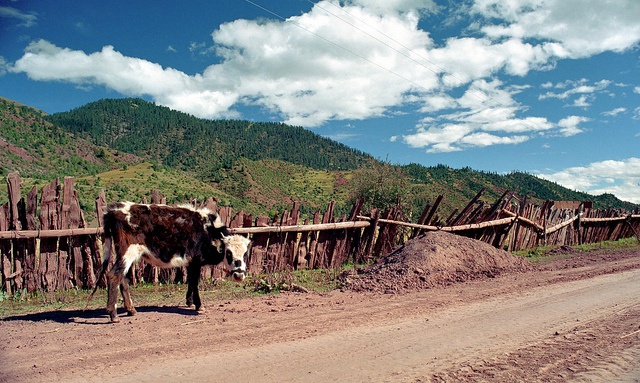Describe the objects in this image and their specific colors. I can see a cow in navy, black, maroon, brown, and ivory tones in this image. 